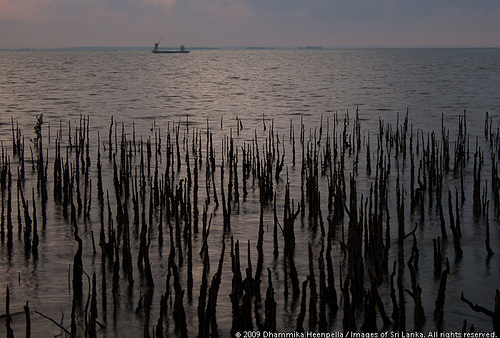<image>
Can you confirm if the tree is on the water? Yes. Looking at the image, I can see the tree is positioned on top of the water, with the water providing support. 